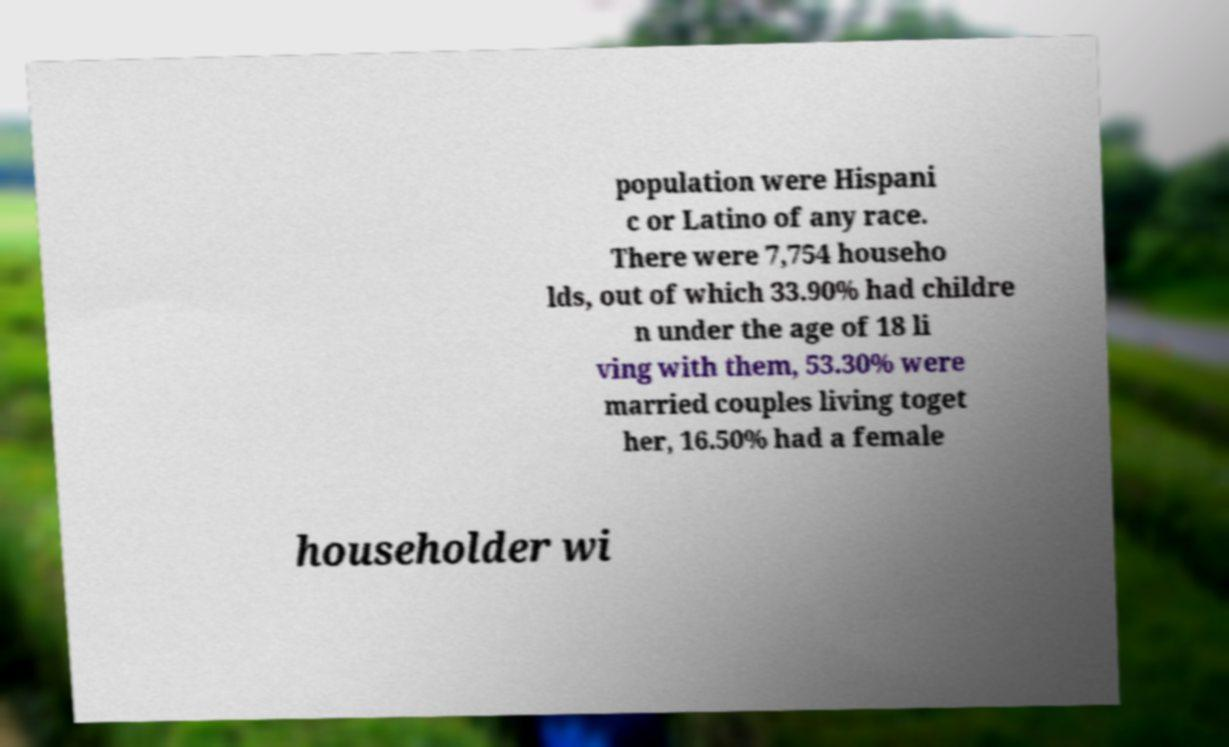Could you extract and type out the text from this image? population were Hispani c or Latino of any race. There were 7,754 househo lds, out of which 33.90% had childre n under the age of 18 li ving with them, 53.30% were married couples living toget her, 16.50% had a female householder wi 